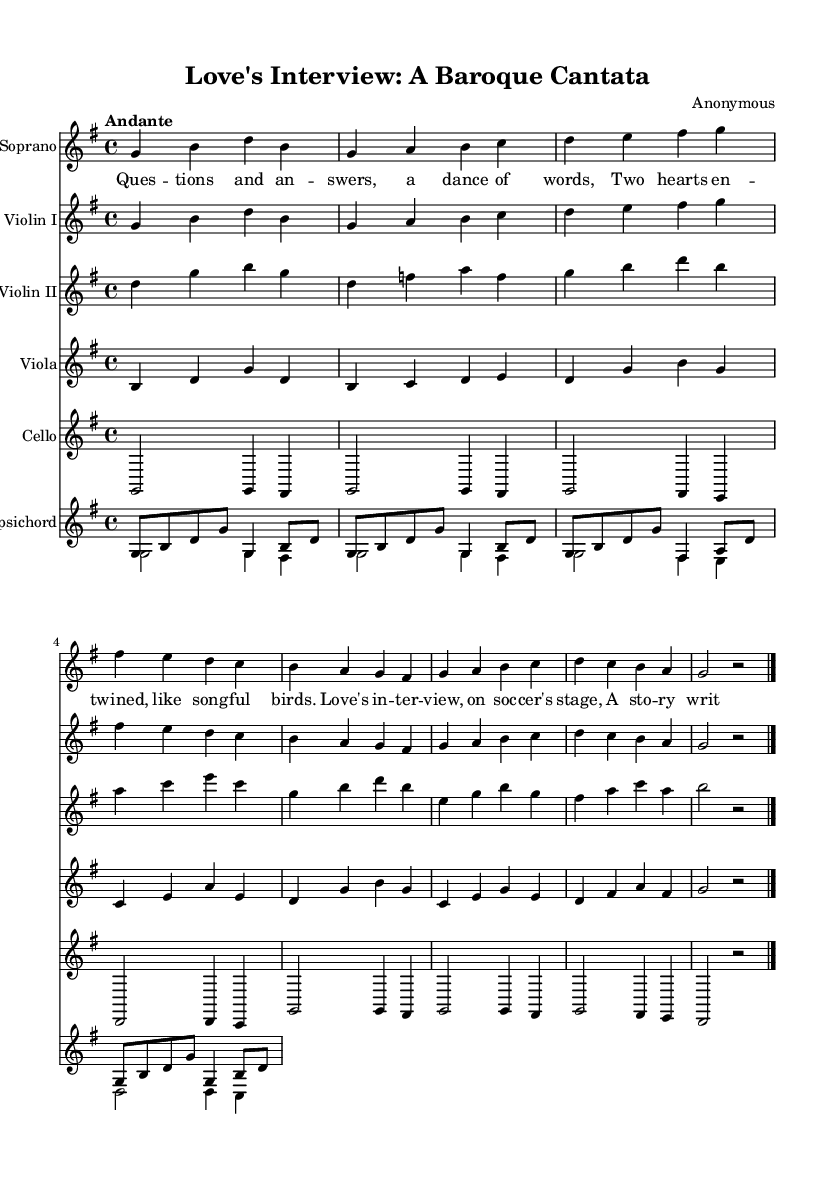What is the key signature of this music? The key signature is indicated at the beginning of the staff, showing one sharp. This indicates that the key signature is G major.
Answer: G major What is the time signature of this music? The time signature is located at the beginning of the sheet music, which indicates how many beats are in each measure. Here, it is shown as 4/4, meaning there are four beats per measure.
Answer: 4/4 What is the tempo marking of this piece? The tempo marking is given at the beginning of the score and is described as "Andante." This suggests a moderate walking pace for the performance.
Answer: Andante How many instruments are included in the score? Counting the instrumental parts listed in the score shows there are five: Soprano, Violin I, Violin II, Viola, Cello, and one Harpsichord. Thus, the total is six instruments.
Answer: Six What is the lyrical theme of this cantata? The lyrics reference the experience of coming together through work, particularly hinting at a dialogue or interaction (like an interview) that metaphorically mirrors romance. This thematic exploration is reinforced in the text.
Answer: Romance through work Which instrument has the melody in the first section? By analyzing the score, the Soprano part emerges prominently at the start and carries the textual melody, which is characteristic of vocal music during the Baroque period.
Answer: Soprano What characteristics indicate this is a Baroque cantata? Several factors suggest this is a Baroque cantata: the use of a small ensemble, the prominent role of the soprano voice, and the expressive lyrical style typical of Baroque music. Additionally, the ornamentation and form point to its stylistic period.
Answer: Instrumentation and textual expression 